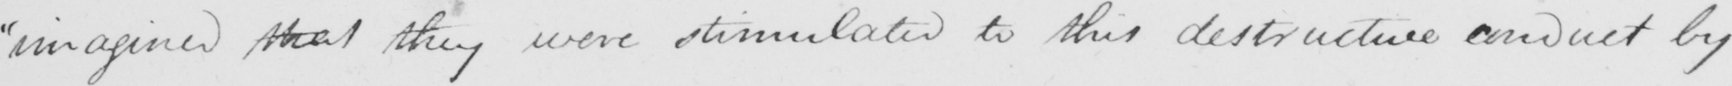What is written in this line of handwriting? "imagined that they were stimulated to this destructive conduct by 